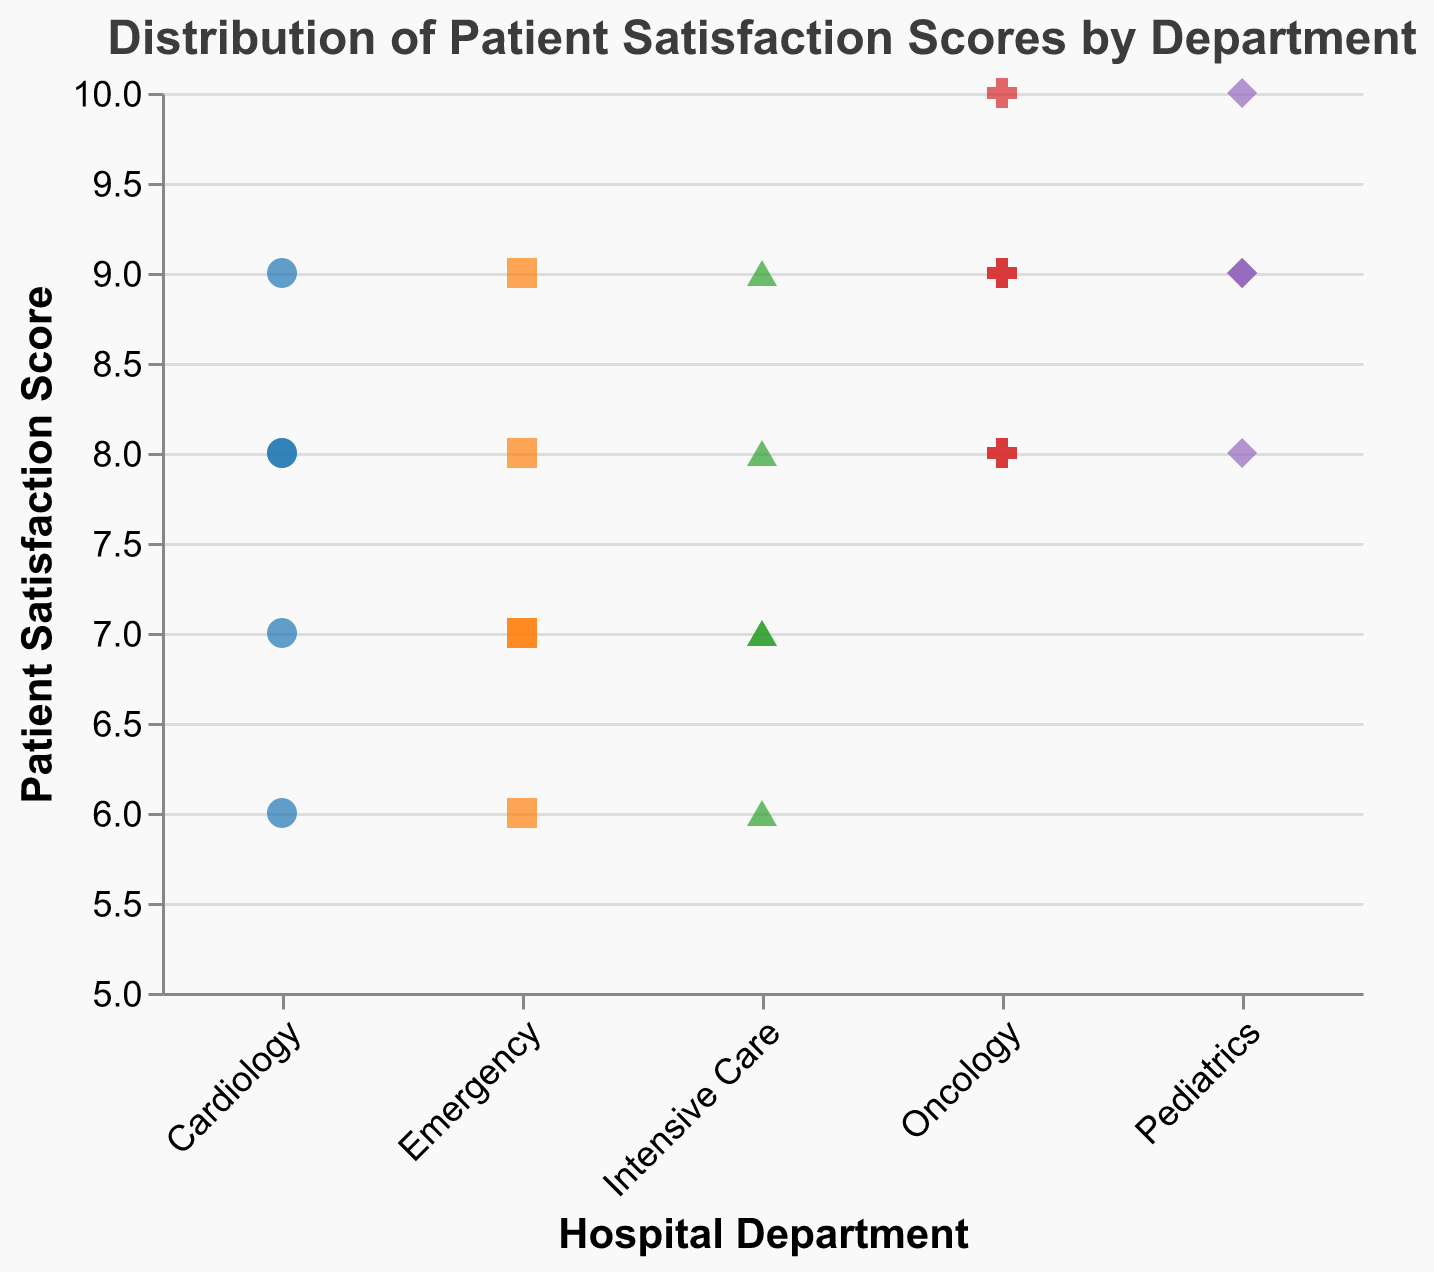What's the title of the chart? The title is usually displayed at the top of the chart. Here, it states "Distribution of Patient Satisfaction Scores by Department."
Answer: Distribution of Patient Satisfaction Scores by Department Which department has the highest satisfaction score? The highest score on the y-axis is 10, and it is marked for Oncology and Pediatrics departments.
Answer: Oncology and Pediatrics How many departments are represented in the chart? By looking at distinct categories along the x-axis, the chart shows the different departments: Emergency, Oncology, Cardiology, Pediatrics, and Intensive Care, totaling five departments.
Answer: 5 What is the satisfaction score range for the Emergency department? The data points corresponding to the Emergency department fall between the y-values 6 and 9.
Answer: 6 to 9 Which department shows the widest range of satisfaction scores? By comparing the range of y-values for each department, Cardiology shows scores between 6 and 9, giving it a range of 3. Other departments have smaller ranges or the same.
Answer: Cardiology Which department seems to have the highest concentration of scores in the high range? The majority of Oncology and Pediatrics scores are clustered around the 9 and 10 marks, indicating a high concentration of high satisfaction scores.
Answer: Oncology and Pediatrics Are there any departments with a satisfaction score of 6? Looking along the y-axis at the score of 6, only Emergency, Cardiology, and Intensive Care have dots on that line.
Answer: Emergency, Cardiology, and Intensive Care What is the average satisfaction score for the Oncology department? The satisfaction scores for Oncology are 9, 8, 10, 9, and 8. Adding these gives 44, and dividing by the 5 scores gives an average of 8.8.
Answer: 8.8 How does the average satisfaction score for Pediatrics compare to that of Cardiology? The satisfaction scores for Pediatrics are 9, 10, 8, 9, and 9, summing to 45, with an average of 9. Cardiology's scores (8, 7, 9, 8, 6) sum to 38 with an average of 7.6. 9 is greater than 7.6, so Pediatrics has the higher average.
Answer: Pediatrics has a higher average Which department has the most varied satisfaction scores? The variation in scores can be measured by the range difference. Cardiology’s scores range from 6 to 9 (range=3), which is more varied compared to other departments like Oncology (range=2) and Pediatrics (range=2).
Answer: Cardiology 